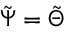Convert formula to latex. <formula><loc_0><loc_0><loc_500><loc_500>\tilde { \Psi } = \tilde { \Theta }</formula> 